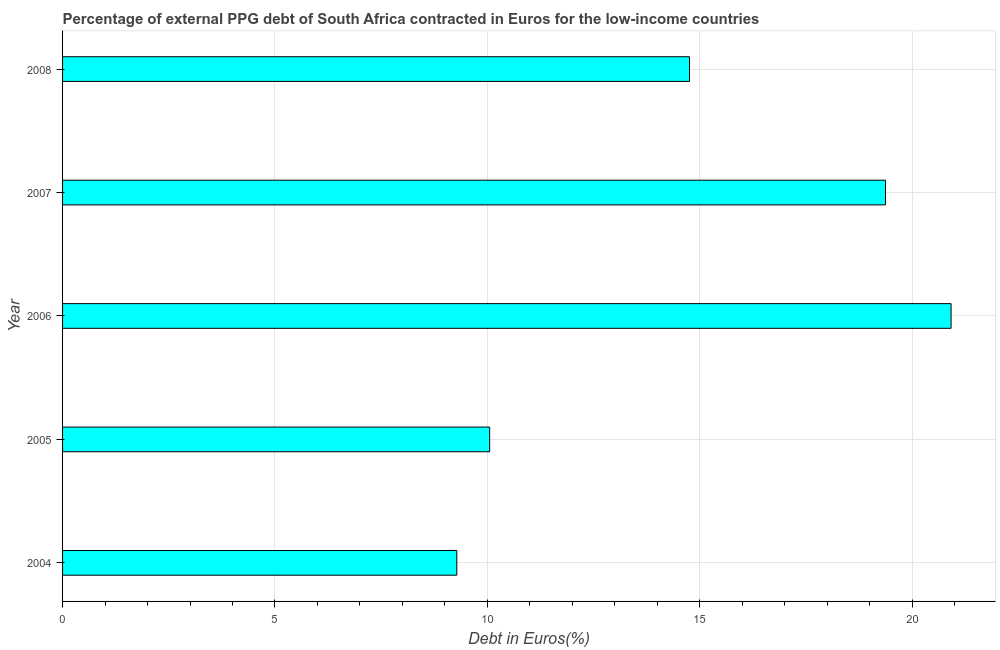Does the graph contain any zero values?
Your response must be concise. No. What is the title of the graph?
Offer a terse response. Percentage of external PPG debt of South Africa contracted in Euros for the low-income countries. What is the label or title of the X-axis?
Provide a succinct answer. Debt in Euros(%). What is the currency composition of ppg debt in 2005?
Keep it short and to the point. 10.05. Across all years, what is the maximum currency composition of ppg debt?
Offer a terse response. 20.91. Across all years, what is the minimum currency composition of ppg debt?
Ensure brevity in your answer.  9.28. In which year was the currency composition of ppg debt minimum?
Your answer should be very brief. 2004. What is the sum of the currency composition of ppg debt?
Keep it short and to the point. 74.38. What is the difference between the currency composition of ppg debt in 2004 and 2007?
Your answer should be compact. -10.09. What is the average currency composition of ppg debt per year?
Offer a very short reply. 14.88. What is the median currency composition of ppg debt?
Ensure brevity in your answer.  14.76. Do a majority of the years between 2006 and 2007 (inclusive) have currency composition of ppg debt greater than 8 %?
Provide a short and direct response. Yes. What is the ratio of the currency composition of ppg debt in 2005 to that in 2008?
Your response must be concise. 0.68. Is the currency composition of ppg debt in 2004 less than that in 2007?
Your response must be concise. Yes. What is the difference between the highest and the second highest currency composition of ppg debt?
Keep it short and to the point. 1.54. Is the sum of the currency composition of ppg debt in 2004 and 2005 greater than the maximum currency composition of ppg debt across all years?
Offer a very short reply. No. What is the difference between the highest and the lowest currency composition of ppg debt?
Ensure brevity in your answer.  11.63. How many years are there in the graph?
Offer a very short reply. 5. Are the values on the major ticks of X-axis written in scientific E-notation?
Offer a terse response. No. What is the Debt in Euros(%) of 2004?
Ensure brevity in your answer.  9.28. What is the Debt in Euros(%) in 2005?
Your answer should be very brief. 10.05. What is the Debt in Euros(%) of 2006?
Give a very brief answer. 20.91. What is the Debt in Euros(%) of 2007?
Your response must be concise. 19.37. What is the Debt in Euros(%) in 2008?
Ensure brevity in your answer.  14.76. What is the difference between the Debt in Euros(%) in 2004 and 2005?
Make the answer very short. -0.77. What is the difference between the Debt in Euros(%) in 2004 and 2006?
Provide a short and direct response. -11.63. What is the difference between the Debt in Euros(%) in 2004 and 2007?
Ensure brevity in your answer.  -10.09. What is the difference between the Debt in Euros(%) in 2004 and 2008?
Your response must be concise. -5.48. What is the difference between the Debt in Euros(%) in 2005 and 2006?
Your answer should be very brief. -10.86. What is the difference between the Debt in Euros(%) in 2005 and 2007?
Your answer should be very brief. -9.32. What is the difference between the Debt in Euros(%) in 2005 and 2008?
Your answer should be very brief. -4.7. What is the difference between the Debt in Euros(%) in 2006 and 2007?
Provide a succinct answer. 1.54. What is the difference between the Debt in Euros(%) in 2006 and 2008?
Offer a terse response. 6.16. What is the difference between the Debt in Euros(%) in 2007 and 2008?
Your answer should be compact. 4.61. What is the ratio of the Debt in Euros(%) in 2004 to that in 2005?
Give a very brief answer. 0.92. What is the ratio of the Debt in Euros(%) in 2004 to that in 2006?
Your answer should be compact. 0.44. What is the ratio of the Debt in Euros(%) in 2004 to that in 2007?
Keep it short and to the point. 0.48. What is the ratio of the Debt in Euros(%) in 2004 to that in 2008?
Your answer should be very brief. 0.63. What is the ratio of the Debt in Euros(%) in 2005 to that in 2006?
Give a very brief answer. 0.48. What is the ratio of the Debt in Euros(%) in 2005 to that in 2007?
Provide a succinct answer. 0.52. What is the ratio of the Debt in Euros(%) in 2005 to that in 2008?
Provide a short and direct response. 0.68. What is the ratio of the Debt in Euros(%) in 2006 to that in 2008?
Your answer should be compact. 1.42. What is the ratio of the Debt in Euros(%) in 2007 to that in 2008?
Offer a very short reply. 1.31. 